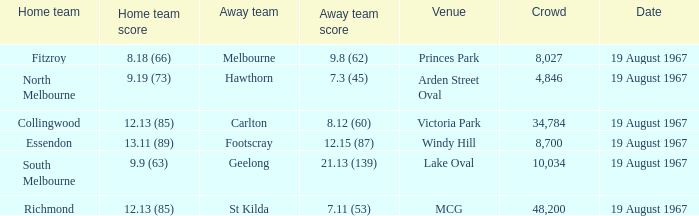When the away team scored 7.11 (53) what venue did they play at? MCG. 